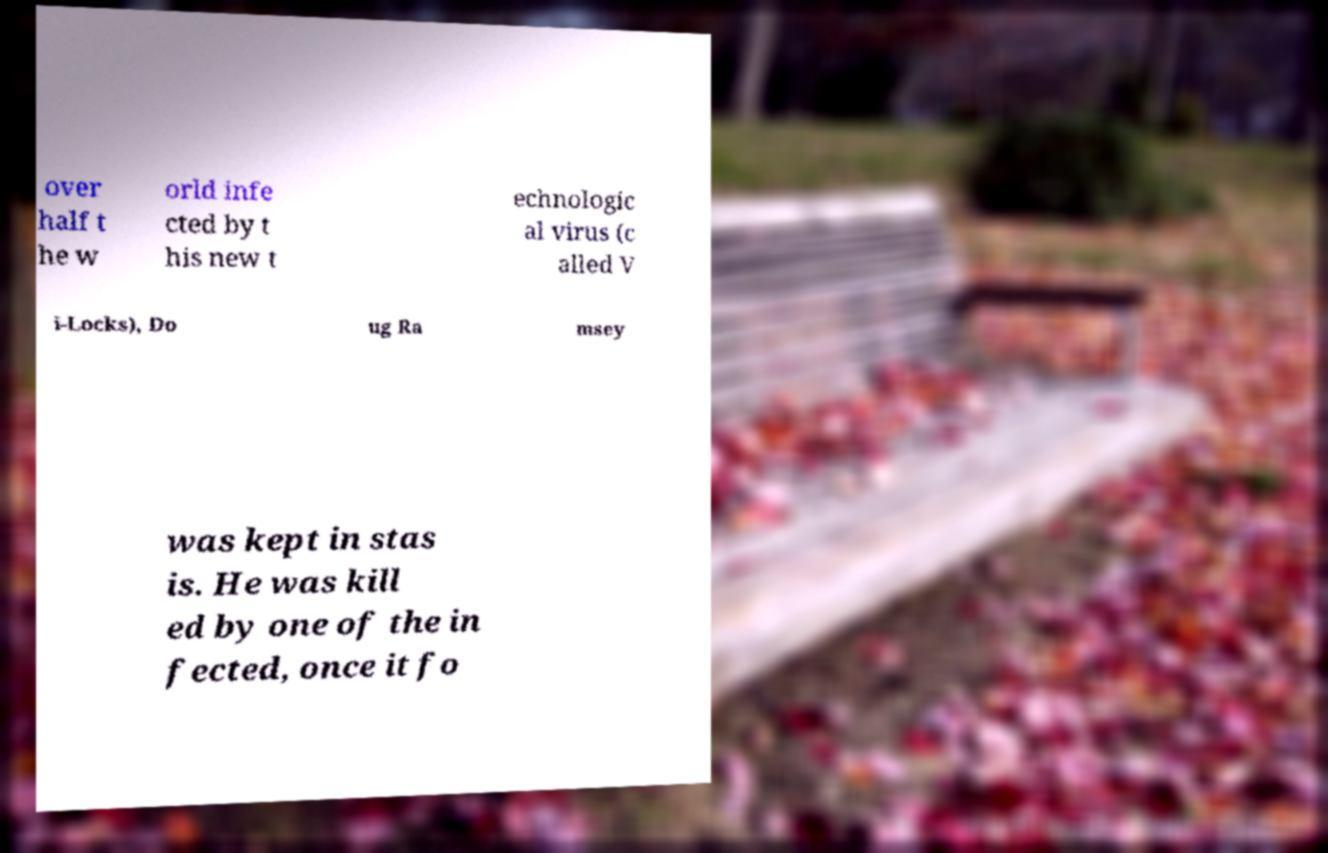I need the written content from this picture converted into text. Can you do that? over half t he w orld infe cted by t his new t echnologic al virus (c alled V i-Locks), Do ug Ra msey was kept in stas is. He was kill ed by one of the in fected, once it fo 